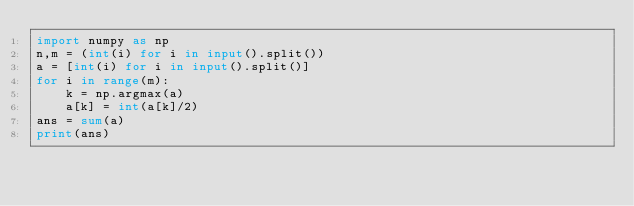Convert code to text. <code><loc_0><loc_0><loc_500><loc_500><_Python_>import numpy as np
n,m = (int(i) for i in input().split())
a = [int(i) for i in input().split()]
for i in range(m):
    k = np.argmax(a)
    a[k] = int(a[k]/2)
ans = sum(a)
print(ans)
</code> 